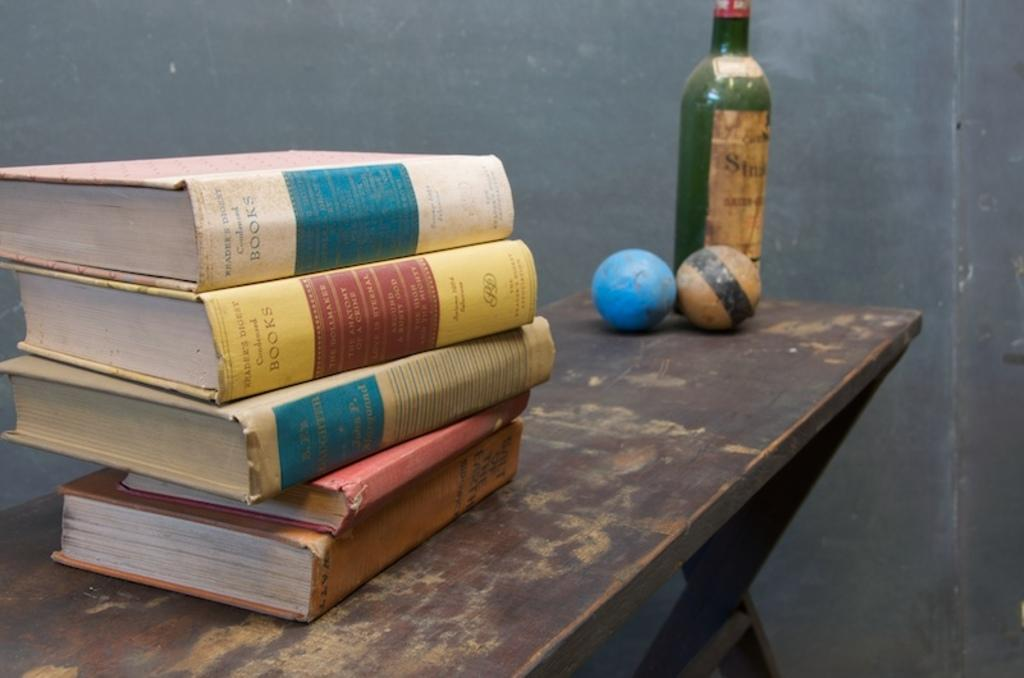What objects can be seen in the image related to reading or learning? There are books in the image. What type of objects can be seen in the image that are typically used for playing? There are two balls in the image. What object in the image might be used for holding or storing liquids? There is a bottle in the image. What type of furniture is present in the image? There is a table in the image. What can be seen in the background of the image that might indicate the setting? There is a wall in the background of the image. What type of bread can be seen in the image? There is no bread present in the image. What type of toys can be seen in the image? There are no toys present in the image. 